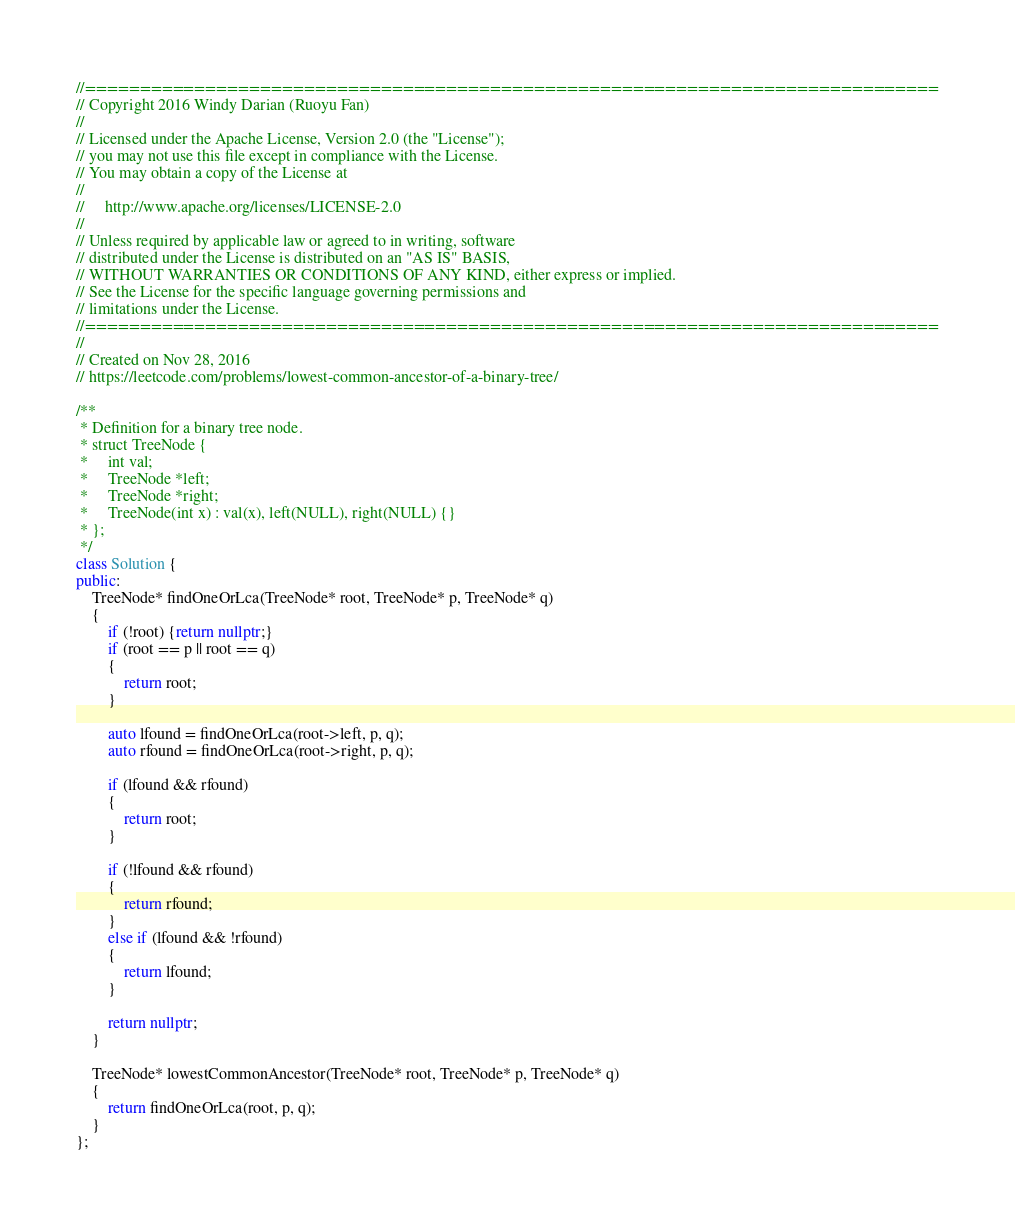Convert code to text. <code><loc_0><loc_0><loc_500><loc_500><_C++_>//==============================================================================
// Copyright 2016 Windy Darian (Ruoyu Fan)
//
// Licensed under the Apache License, Version 2.0 (the "License");
// you may not use this file except in compliance with the License.
// You may obtain a copy of the License at
//
//     http://www.apache.org/licenses/LICENSE-2.0
//
// Unless required by applicable law or agreed to in writing, software
// distributed under the License is distributed on an "AS IS" BASIS,
// WITHOUT WARRANTIES OR CONDITIONS OF ANY KIND, either express or implied.
// See the License for the specific language governing permissions and
// limitations under the License.
//==============================================================================
//
// Created on Nov 28, 2016
// https://leetcode.com/problems/lowest-common-ancestor-of-a-binary-tree/

/**
 * Definition for a binary tree node.
 * struct TreeNode {
 *     int val;
 *     TreeNode *left;
 *     TreeNode *right;
 *     TreeNode(int x) : val(x), left(NULL), right(NULL) {}
 * };
 */
class Solution {
public:
    TreeNode* findOneOrLca(TreeNode* root, TreeNode* p, TreeNode* q)
    {
        if (!root) {return nullptr;}
        if (root == p || root == q)
        {
            return root;
        }

        auto lfound = findOneOrLca(root->left, p, q);
        auto rfound = findOneOrLca(root->right, p, q);

        if (lfound && rfound)
        {
            return root;
        }

        if (!lfound && rfound)
        {
            return rfound;
        }
        else if (lfound && !rfound)
        {
            return lfound;
        }

        return nullptr;
    }

    TreeNode* lowestCommonAncestor(TreeNode* root, TreeNode* p, TreeNode* q)
    {
        return findOneOrLca(root, p, q);
    }
};
</code> 